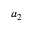Convert formula to latex. <formula><loc_0><loc_0><loc_500><loc_500>a _ { 2 }</formula> 